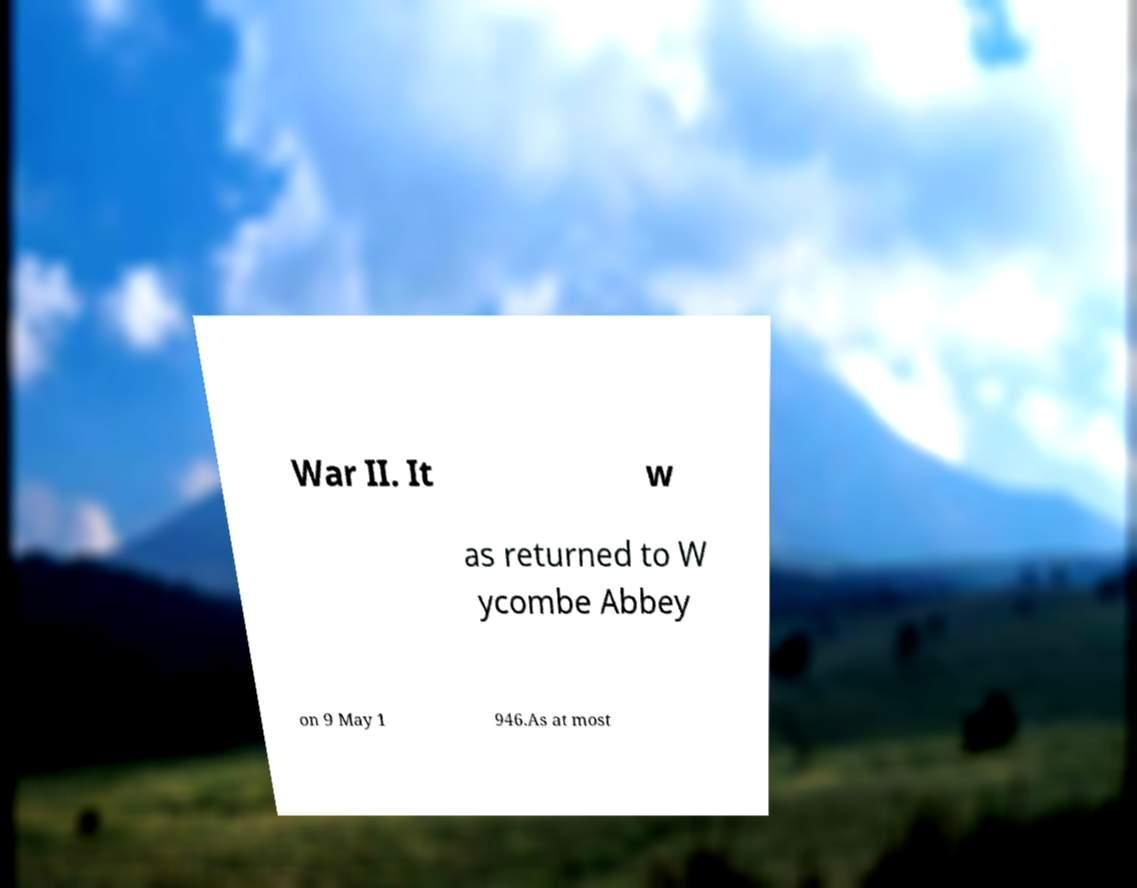There's text embedded in this image that I need extracted. Can you transcribe it verbatim? War II. It w as returned to W ycombe Abbey on 9 May 1 946.As at most 